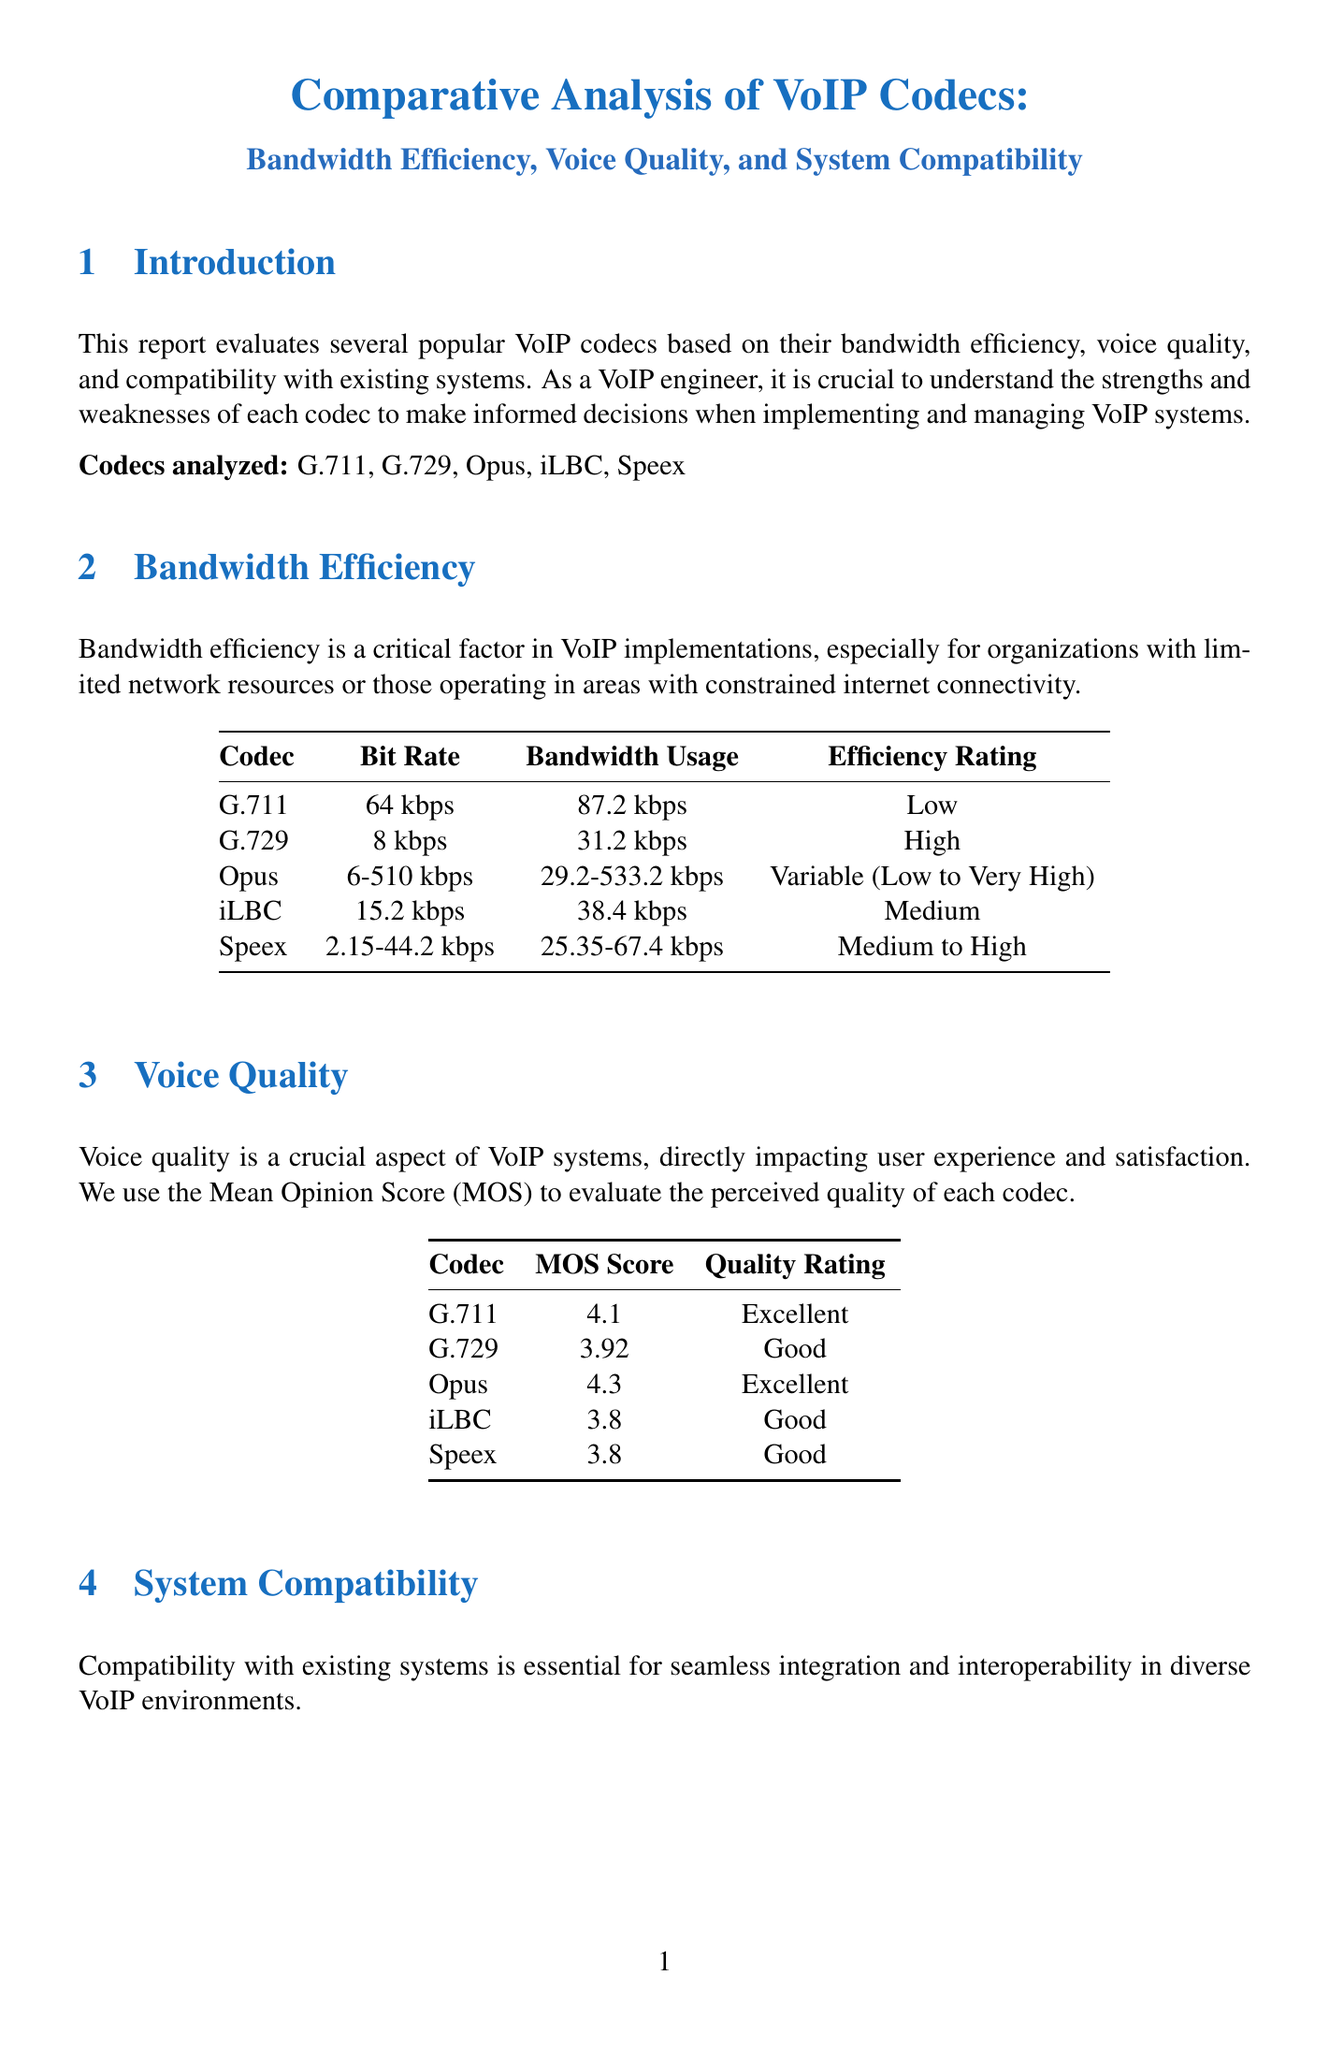What is the title of the report? The title of the report is presented at the beginning, summarizing the analysis focused on VoIP codecs.
Answer: Comparative Analysis of VoIP Codecs: Bandwidth Efficiency, Voice Quality, and System Compatibility Which codec has the highest MOS score? The MOS score table indicates the perceived quality of each codec, with Opus having the highest score.
Answer: Opus What is the bit rate of G.729? The bandwidth efficiency comparison table provides the bit rate for G.729 specifically.
Answer: 8 kbps How is the bandwidth efficiency of G.711 rated? The efficiency rating for G.711 is found in the bandwidth efficiency comparison table.
Answer: Low Which codec is recommended for web-based VoIP applications? The use case scenarios section specifies which codec is best for that application.
Answer: Opus How does Opus rate in terms of hardware support? The system compatibility section details hardware support ratings for each codec, with Opus rated accordingly.
Answer: Moderate What is the quality rating of iLBC? The voice quality table lists the quality rating for iLBC explicitly.
Answer: Good What are two recommended codecs for mobile VoIP applications? The use case scenarios provide information on suitable codecs for mobile applications.
Answer: Speex 